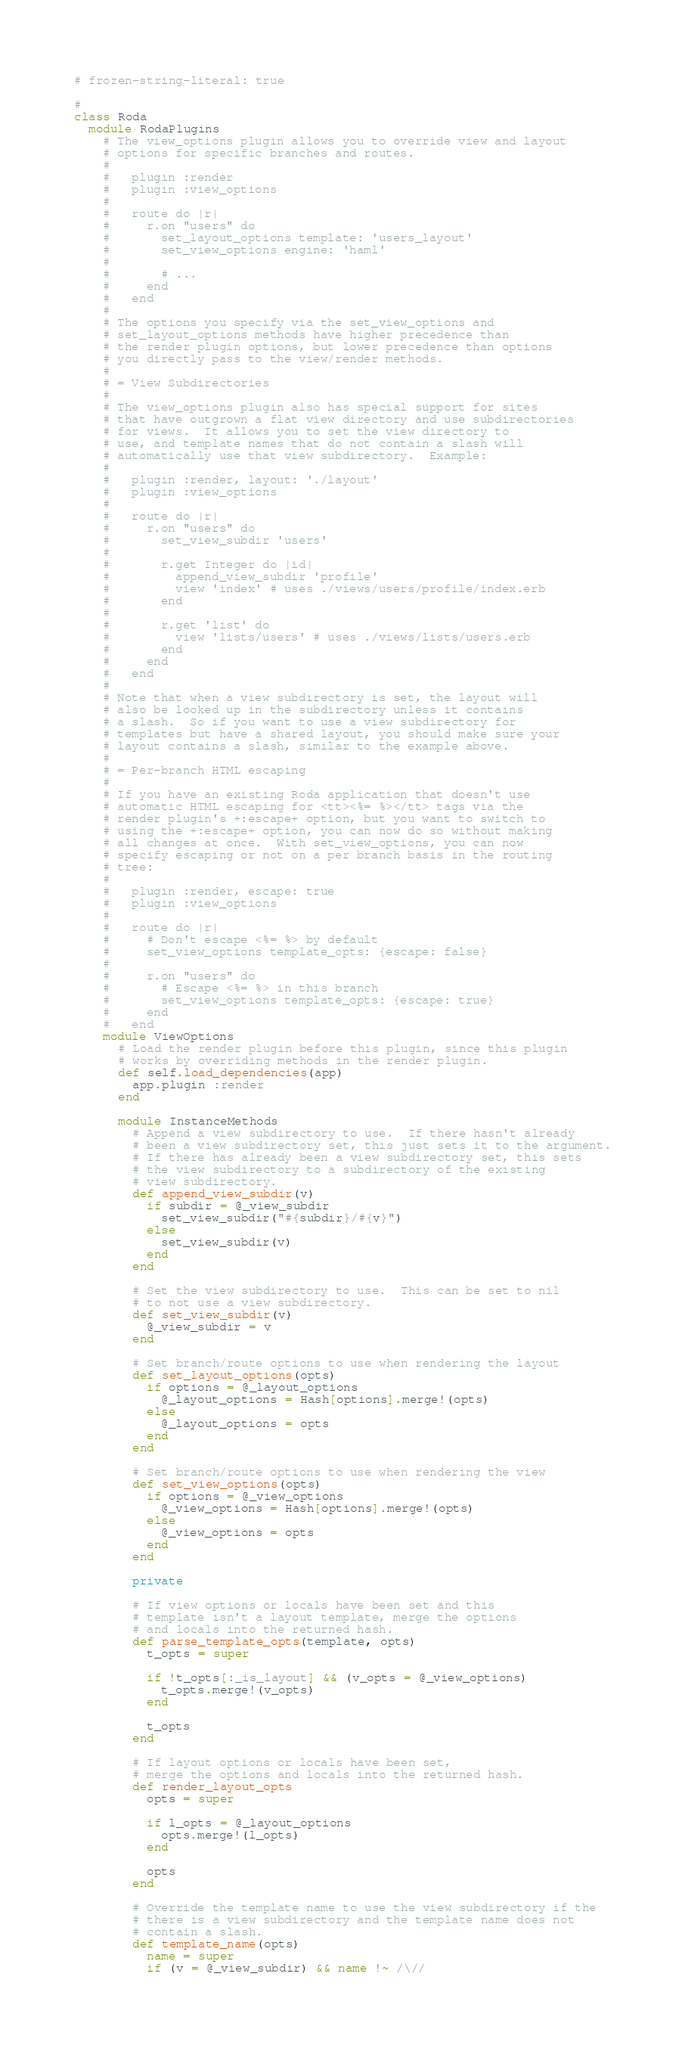<code> <loc_0><loc_0><loc_500><loc_500><_Ruby_># frozen-string-literal: true

#
class Roda
  module RodaPlugins
    # The view_options plugin allows you to override view and layout
    # options for specific branches and routes.
    #
    #   plugin :render
    #   plugin :view_options
    #
    #   route do |r|
    #     r.on "users" do
    #       set_layout_options template: 'users_layout'
    #       set_view_options engine: 'haml'
    #
    #       # ...
    #     end
    #   end
    #
    # The options you specify via the set_view_options and
    # set_layout_options methods have higher precedence than
    # the render plugin options, but lower precedence than options
    # you directly pass to the view/render methods.
    #
    # = View Subdirectories
    #
    # The view_options plugin also has special support for sites
    # that have outgrown a flat view directory and use subdirectories
    # for views.  It allows you to set the view directory to
    # use, and template names that do not contain a slash will
    # automatically use that view subdirectory.  Example:
    #
    #   plugin :render, layout: './layout'
    #   plugin :view_options
    #
    #   route do |r|
    #     r.on "users" do
    #       set_view_subdir 'users'
    #       
    #       r.get Integer do |id|
    #         append_view_subdir 'profile'
    #         view 'index' # uses ./views/users/profile/index.erb
    #       end
    #
    #       r.get 'list' do
    #         view 'lists/users' # uses ./views/lists/users.erb
    #       end
    #     end
    #   end
    #
    # Note that when a view subdirectory is set, the layout will
    # also be looked up in the subdirectory unless it contains
    # a slash.  So if you want to use a view subdirectory for
    # templates but have a shared layout, you should make sure your
    # layout contains a slash, similar to the example above.
    #
    # = Per-branch HTML escaping
    #
    # If you have an existing Roda application that doesn't use
    # automatic HTML escaping for <tt><%= %></tt> tags via the
    # render plugin's +:escape+ option, but you want to switch to
    # using the +:escape+ option, you can now do so without making
    # all changes at once.  With set_view_options, you can now
    # specify escaping or not on a per branch basis in the routing
    # tree:
    #
    #   plugin :render, escape: true
    #   plugin :view_options
    #
    #   route do |r|
    #     # Don't escape <%= %> by default
    #     set_view_options template_opts: {escape: false}
    #
    #     r.on "users" do
    #       # Escape <%= %> in this branch
    #       set_view_options template_opts: {escape: true}
    #     end
    #   end
    module ViewOptions
      # Load the render plugin before this plugin, since this plugin
      # works by overriding methods in the render plugin.
      def self.load_dependencies(app)
        app.plugin :render
      end

      module InstanceMethods
        # Append a view subdirectory to use.  If there hasn't already
        # been a view subdirectory set, this just sets it to the argument.
        # If there has already been a view subdirectory set, this sets
        # the view subdirectory to a subdirectory of the existing
        # view subdirectory.
        def append_view_subdir(v)
          if subdir = @_view_subdir
            set_view_subdir("#{subdir}/#{v}")
          else
            set_view_subdir(v)
          end
        end

        # Set the view subdirectory to use.  This can be set to nil
        # to not use a view subdirectory.
        def set_view_subdir(v)
          @_view_subdir = v
        end

        # Set branch/route options to use when rendering the layout
        def set_layout_options(opts)
          if options = @_layout_options
            @_layout_options = Hash[options].merge!(opts)
          else
            @_layout_options = opts
          end
        end

        # Set branch/route options to use when rendering the view
        def set_view_options(opts)
          if options = @_view_options
            @_view_options = Hash[options].merge!(opts)
          else
            @_view_options = opts
          end
        end

        private

        # If view options or locals have been set and this
        # template isn't a layout template, merge the options
        # and locals into the returned hash.
        def parse_template_opts(template, opts)
          t_opts = super

          if !t_opts[:_is_layout] && (v_opts = @_view_options)
            t_opts.merge!(v_opts)
          end

          t_opts
        end

        # If layout options or locals have been set,
        # merge the options and locals into the returned hash.
        def render_layout_opts
          opts = super

          if l_opts = @_layout_options
            opts.merge!(l_opts)
          end

          opts
        end

        # Override the template name to use the view subdirectory if the
        # there is a view subdirectory and the template name does not
        # contain a slash.
        def template_name(opts)
          name = super
          if (v = @_view_subdir) && name !~ /\//</code> 